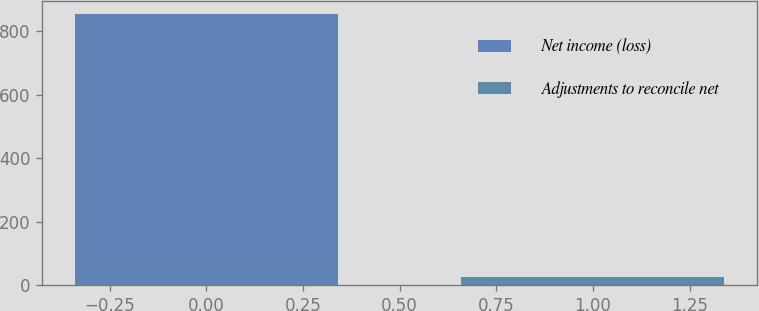Convert chart to OTSL. <chart><loc_0><loc_0><loc_500><loc_500><bar_chart><fcel>Net income (loss)<fcel>Adjustments to reconcile net<nl><fcel>853<fcel>27<nl></chart> 